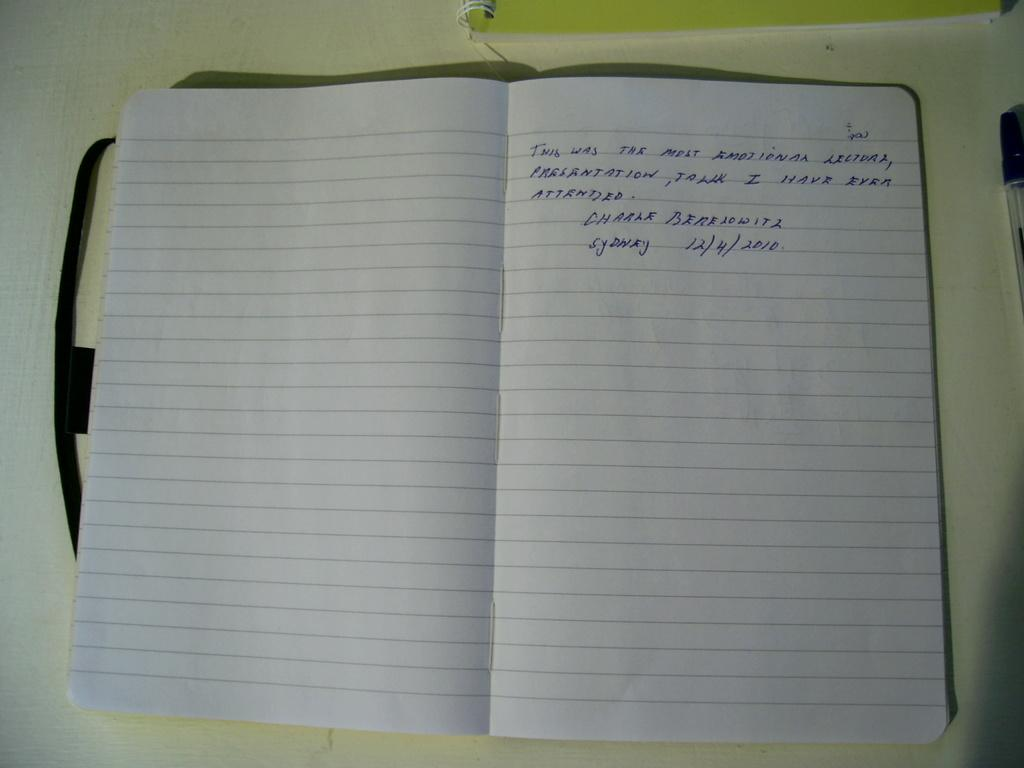<image>
Summarize the visual content of the image. Handwritten notes in a lined notebook include the city name of Sydney and the date 12/4/2010. 